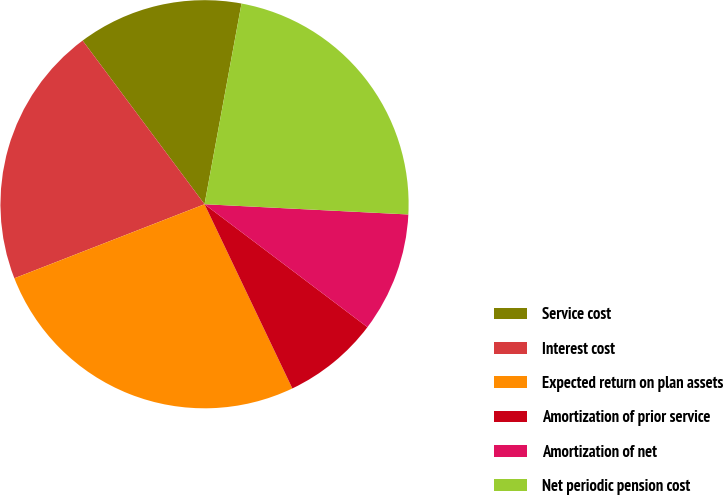<chart> <loc_0><loc_0><loc_500><loc_500><pie_chart><fcel>Service cost<fcel>Interest cost<fcel>Expected return on plan assets<fcel>Amortization of prior service<fcel>Amortization of net<fcel>Net periodic pension cost<nl><fcel>13.09%<fcel>20.72%<fcel>26.17%<fcel>7.63%<fcel>9.49%<fcel>22.9%<nl></chart> 